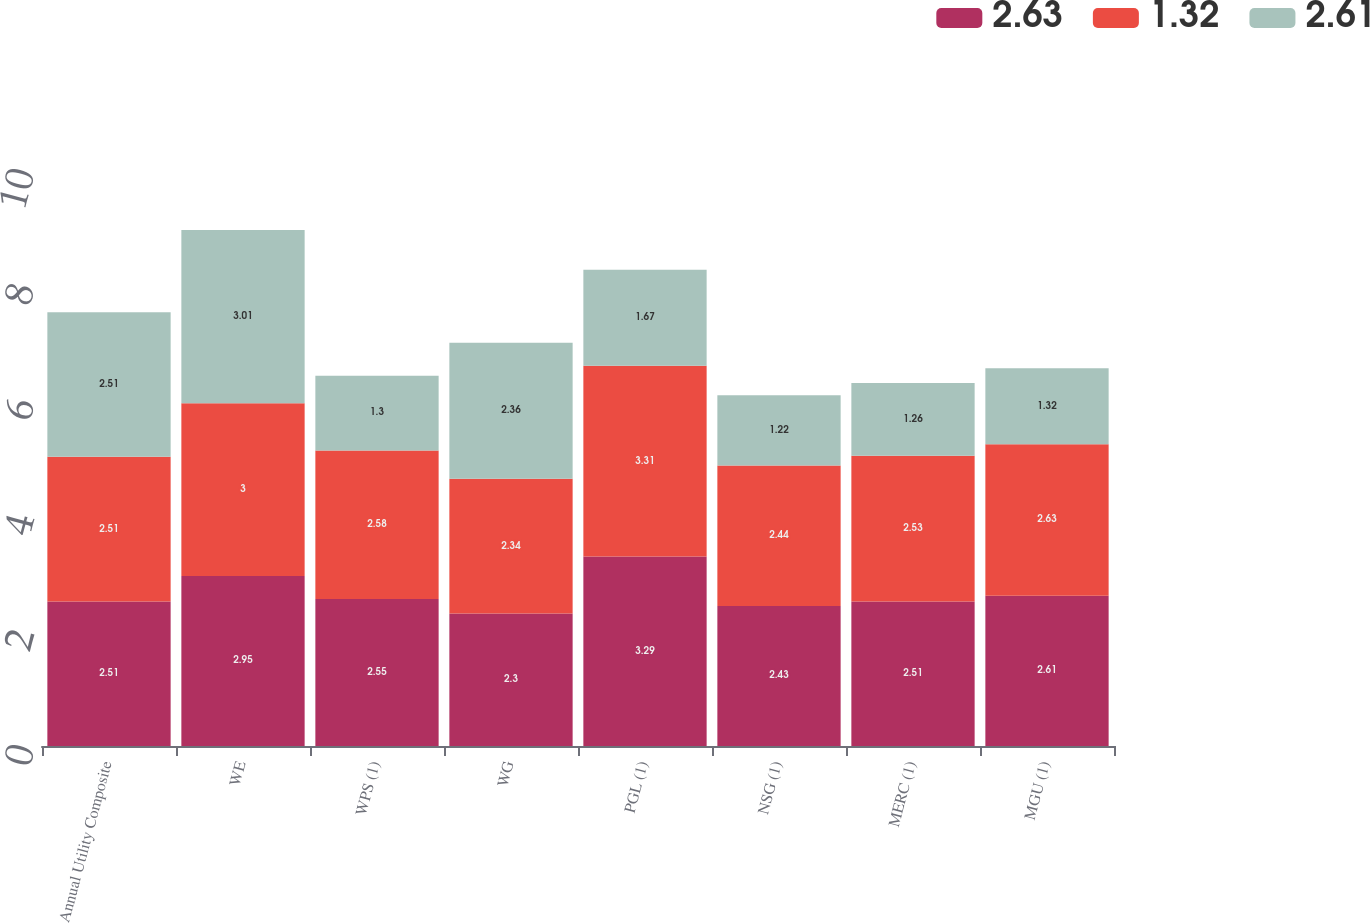Convert chart to OTSL. <chart><loc_0><loc_0><loc_500><loc_500><stacked_bar_chart><ecel><fcel>Annual Utility Composite<fcel>WE<fcel>WPS (1)<fcel>WG<fcel>PGL (1)<fcel>NSG (1)<fcel>MERC (1)<fcel>MGU (1)<nl><fcel>2.63<fcel>2.51<fcel>2.95<fcel>2.55<fcel>2.3<fcel>3.29<fcel>2.43<fcel>2.51<fcel>2.61<nl><fcel>1.32<fcel>2.51<fcel>3<fcel>2.58<fcel>2.34<fcel>3.31<fcel>2.44<fcel>2.53<fcel>2.63<nl><fcel>2.61<fcel>2.51<fcel>3.01<fcel>1.3<fcel>2.36<fcel>1.67<fcel>1.22<fcel>1.26<fcel>1.32<nl></chart> 